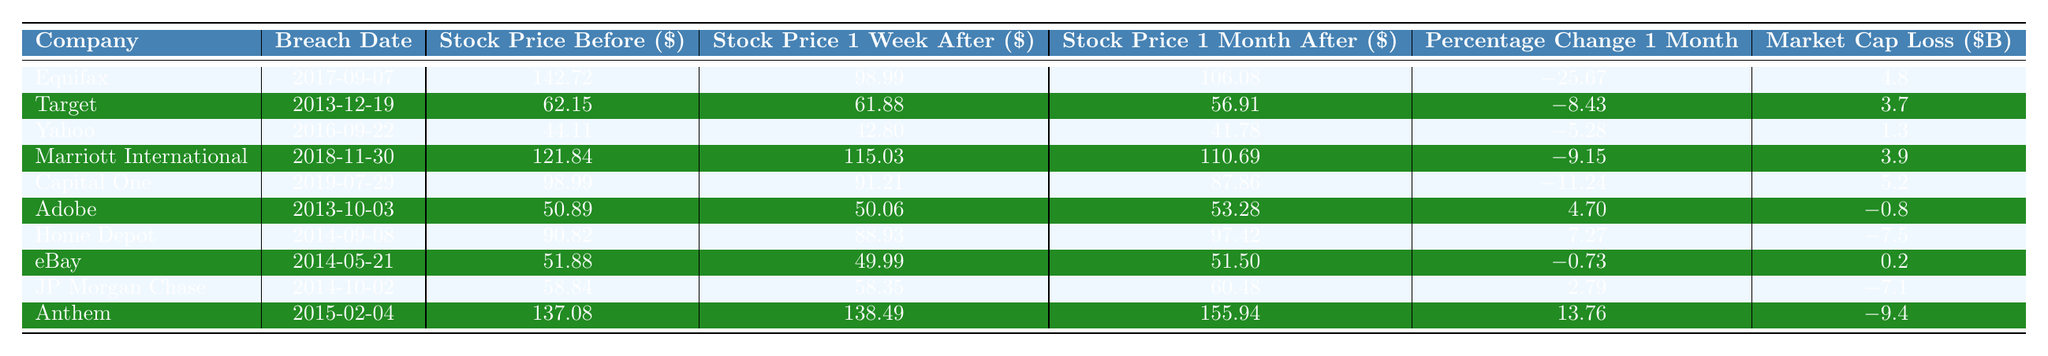What was Equifax's stock price before the breach? The table shows that Equifax had a stock price of $142.72 before the breach occurred on September 7, 2017.
Answer: 142.72 What was the percentage change in stock price for Target one month after the breach? The table indicates that Target experienced a percentage change of -8.43% one month after the breach that occurred on December 19, 2013.
Answer: -8.43 Did Adobe's stock price increase or decrease one month after its breach? According to the table, Adobe's stock price was $50.89 before the breach and $53.28 one month later, indicating an increase.
Answer: Yes Which company had the highest market cap loss? By examining the market cap loss values in the table, Equifax had a loss of $4.8 billion, which is the highest among the listed companies.
Answer: 4.8 What is the average stock price change one month after the breach for the listed companies? The stock price changes after the breach can be summed up: (-25.67 + -8.43 + -5.28 + -9.15 + -11.24 + 4.70 + 7.27 + -0.73 + 2.79 + 13.76) = -32.82. Dividing by 10 gives the average change of -3.282%.
Answer: -3.28 Which company had a stock price one month after the breach higher than its price before the breach? The only company that had a stock price increase one month after the breach was Anthem, with a price increase from $137.08 to $155.94.
Answer: Anthem How much did the stock price of Home Depot change one month after the breach? Home Depot's stock price was $90.82 before the breach and increased to $97.42 one month later, which equates to a change of +7.27%.
Answer: 7.27 Which company saw the smallest market cap loss? By reviewing the market cap losses, Adobe had the smallest loss at -$0.8 billion in the table.
Answer: -0.8 How does the stock price change one month after the breach compare between Capital One and Yahoo? Capital One's stock decreased by 11.24%, while Yahoo's stock decreased by only 5.28% one month after their respective breaches, indicating Capital One had a larger loss in stock price.
Answer: Capital One had a larger loss What was the stock price for JP Morgan Chase one week after the breach? The table shows that JP Morgan Chase's stock price dropped to $58.35 one week after the breach on October 2, 2014.
Answer: 58.35 